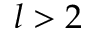<formula> <loc_0><loc_0><loc_500><loc_500>l > 2</formula> 